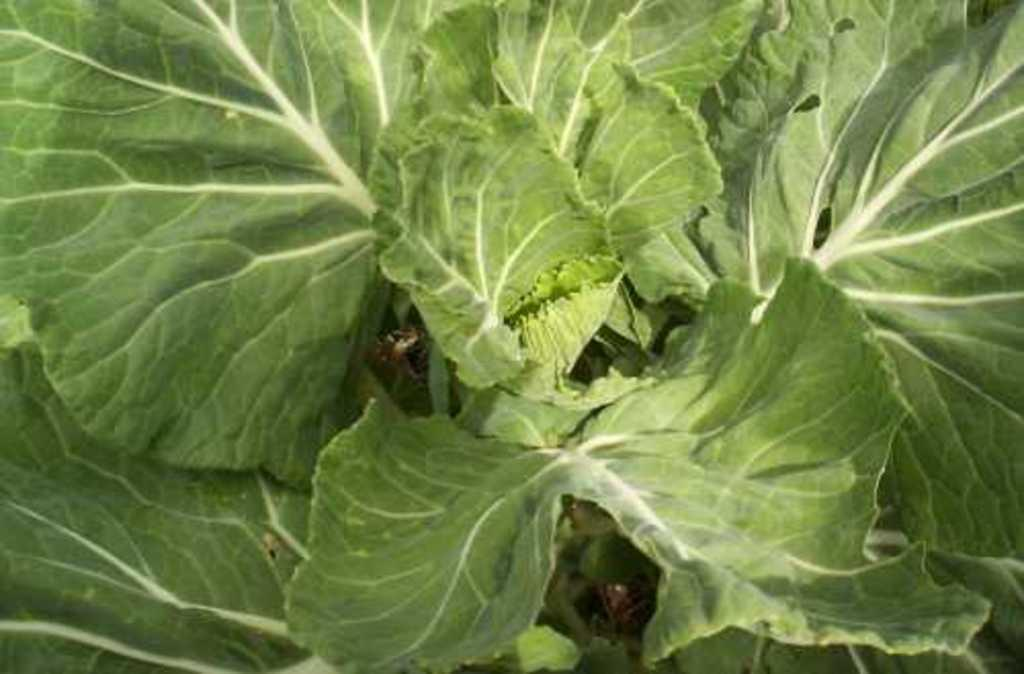What is present in the image? There is a plant in the image. Can you describe the plant in more detail? The plant has many leaves. How does the crowd affect the growth of the plant in the image? There is no crowd present in the image, so this question cannot be answered. 